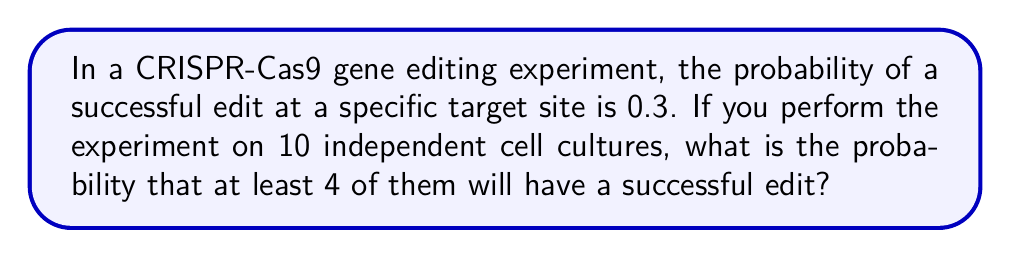Give your solution to this math problem. To solve this problem, we need to use the binomial probability distribution. Let's break it down step-by-step:

1) We can model this as a binomial experiment because:
   - There are a fixed number of trials (n = 10 cell cultures)
   - Each trial has two possible outcomes (success or failure)
   - The probability of success is constant for each trial (p = 0.3)
   - The trials are independent

2) We want to find the probability of 4 or more successes out of 10 trials. This can be calculated as:

   P(X ≥ 4) = 1 - P(X < 4) = 1 - [P(X = 0) + P(X = 1) + P(X = 2) + P(X = 3)]

3) The binomial probability formula is:

   $$P(X = k) = \binom{n}{k} p^k (1-p)^{n-k}$$

   Where n is the number of trials, k is the number of successes, p is the probability of success.

4) Let's calculate each term:

   P(X = 0) = $\binom{10}{0} (0.3)^0 (0.7)^{10}$ = 0.0282
   P(X = 1) = $\binom{10}{1} (0.3)^1 (0.7)^9$ = 0.1211
   P(X = 2) = $\binom{10}{2} (0.3)^2 (0.7)^8$ = 0.2335
   P(X = 3) = $\binom{10}{3} (0.3)^3 (0.7)^7$ = 0.2668

5) Now we can sum these probabilities:

   P(X < 4) = 0.0282 + 0.1211 + 0.2335 + 0.2668 = 0.6496

6) Finally, we can calculate the probability of 4 or more successes:

   P(X ≥ 4) = 1 - P(X < 4) = 1 - 0.6496 = 0.3504

Therefore, the probability of at least 4 successful edits out of 10 cell cultures is approximately 0.3504 or 35.04%.
Answer: 0.3504 